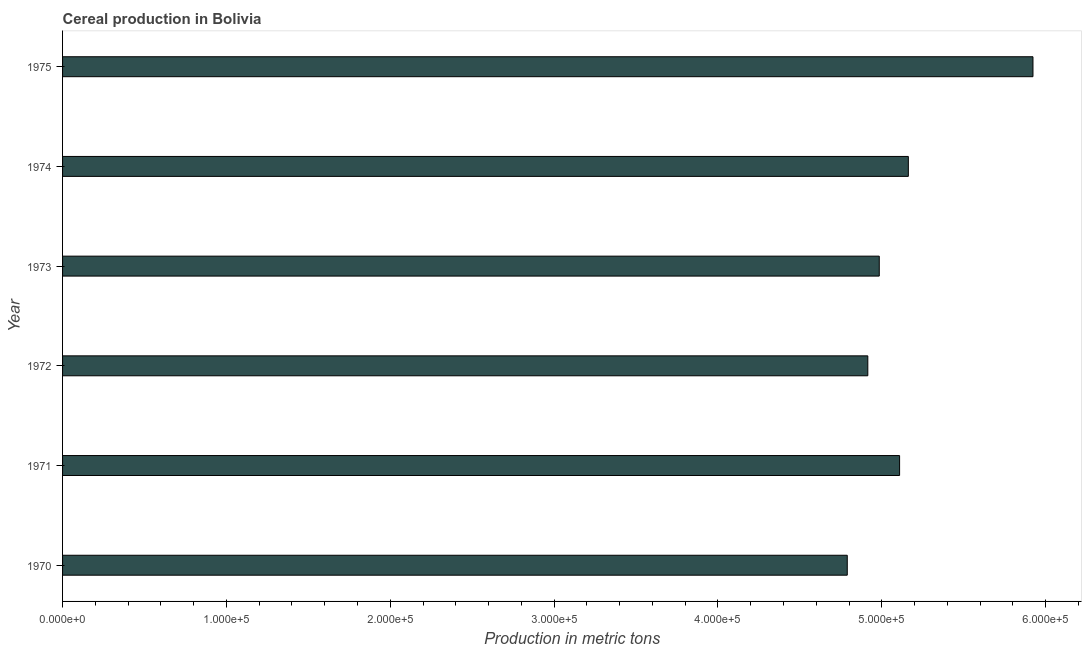What is the title of the graph?
Your answer should be compact. Cereal production in Bolivia. What is the label or title of the X-axis?
Your answer should be very brief. Production in metric tons. What is the label or title of the Y-axis?
Your answer should be compact. Year. What is the cereal production in 1973?
Give a very brief answer. 4.98e+05. Across all years, what is the maximum cereal production?
Offer a very short reply. 5.92e+05. Across all years, what is the minimum cereal production?
Offer a terse response. 4.79e+05. In which year was the cereal production maximum?
Give a very brief answer. 1975. In which year was the cereal production minimum?
Offer a very short reply. 1970. What is the sum of the cereal production?
Make the answer very short. 3.09e+06. What is the difference between the cereal production in 1972 and 1973?
Offer a very short reply. -6990. What is the average cereal production per year?
Your answer should be compact. 5.15e+05. What is the median cereal production?
Provide a short and direct response. 5.05e+05. What is the ratio of the cereal production in 1970 to that in 1975?
Offer a terse response. 0.81. Is the cereal production in 1971 less than that in 1973?
Ensure brevity in your answer.  No. What is the difference between the highest and the second highest cereal production?
Your answer should be very brief. 7.61e+04. What is the difference between the highest and the lowest cereal production?
Provide a short and direct response. 1.13e+05. Are all the bars in the graph horizontal?
Provide a succinct answer. Yes. What is the difference between two consecutive major ticks on the X-axis?
Your answer should be very brief. 1.00e+05. Are the values on the major ticks of X-axis written in scientific E-notation?
Your answer should be compact. Yes. What is the Production in metric tons of 1970?
Make the answer very short. 4.79e+05. What is the Production in metric tons in 1971?
Keep it short and to the point. 5.11e+05. What is the Production in metric tons in 1972?
Your response must be concise. 4.91e+05. What is the Production in metric tons in 1973?
Keep it short and to the point. 4.98e+05. What is the Production in metric tons of 1974?
Ensure brevity in your answer.  5.16e+05. What is the Production in metric tons of 1975?
Your answer should be very brief. 5.92e+05. What is the difference between the Production in metric tons in 1970 and 1971?
Offer a terse response. -3.19e+04. What is the difference between the Production in metric tons in 1970 and 1972?
Provide a short and direct response. -1.25e+04. What is the difference between the Production in metric tons in 1970 and 1973?
Ensure brevity in your answer.  -1.95e+04. What is the difference between the Production in metric tons in 1970 and 1974?
Provide a succinct answer. -3.73e+04. What is the difference between the Production in metric tons in 1970 and 1975?
Offer a very short reply. -1.13e+05. What is the difference between the Production in metric tons in 1971 and 1972?
Offer a terse response. 1.94e+04. What is the difference between the Production in metric tons in 1971 and 1973?
Provide a succinct answer. 1.24e+04. What is the difference between the Production in metric tons in 1971 and 1974?
Give a very brief answer. -5336. What is the difference between the Production in metric tons in 1971 and 1975?
Ensure brevity in your answer.  -8.14e+04. What is the difference between the Production in metric tons in 1972 and 1973?
Make the answer very short. -6990. What is the difference between the Production in metric tons in 1972 and 1974?
Make the answer very short. -2.47e+04. What is the difference between the Production in metric tons in 1972 and 1975?
Provide a succinct answer. -1.01e+05. What is the difference between the Production in metric tons in 1973 and 1974?
Give a very brief answer. -1.78e+04. What is the difference between the Production in metric tons in 1973 and 1975?
Give a very brief answer. -9.38e+04. What is the difference between the Production in metric tons in 1974 and 1975?
Provide a succinct answer. -7.61e+04. What is the ratio of the Production in metric tons in 1970 to that in 1971?
Provide a succinct answer. 0.94. What is the ratio of the Production in metric tons in 1970 to that in 1972?
Your response must be concise. 0.97. What is the ratio of the Production in metric tons in 1970 to that in 1974?
Your answer should be compact. 0.93. What is the ratio of the Production in metric tons in 1970 to that in 1975?
Keep it short and to the point. 0.81. What is the ratio of the Production in metric tons in 1971 to that in 1972?
Offer a terse response. 1.04. What is the ratio of the Production in metric tons in 1971 to that in 1975?
Your answer should be very brief. 0.86. What is the ratio of the Production in metric tons in 1972 to that in 1974?
Provide a short and direct response. 0.95. What is the ratio of the Production in metric tons in 1972 to that in 1975?
Make the answer very short. 0.83. What is the ratio of the Production in metric tons in 1973 to that in 1974?
Your answer should be compact. 0.97. What is the ratio of the Production in metric tons in 1973 to that in 1975?
Your answer should be very brief. 0.84. What is the ratio of the Production in metric tons in 1974 to that in 1975?
Ensure brevity in your answer.  0.87. 